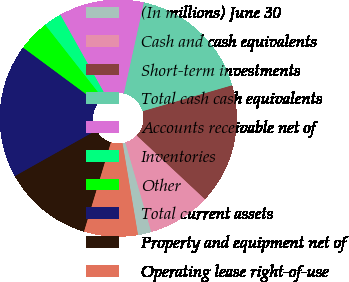Convert chart to OTSL. <chart><loc_0><loc_0><loc_500><loc_500><pie_chart><fcel>(In millions) June 30<fcel>Cash and cash equivalents<fcel>Short-term investments<fcel>Total cash cash equivalents<fcel>Accounts receivable net of<fcel>Inventories<fcel>Other<fcel>Total current assets<fcel>Property and equipment net of<fcel>Operating lease right-of-use<nl><fcel>1.84%<fcel>8.54%<fcel>16.45%<fcel>17.06%<fcel>11.58%<fcel>2.45%<fcel>4.28%<fcel>18.28%<fcel>12.19%<fcel>7.32%<nl></chart> 